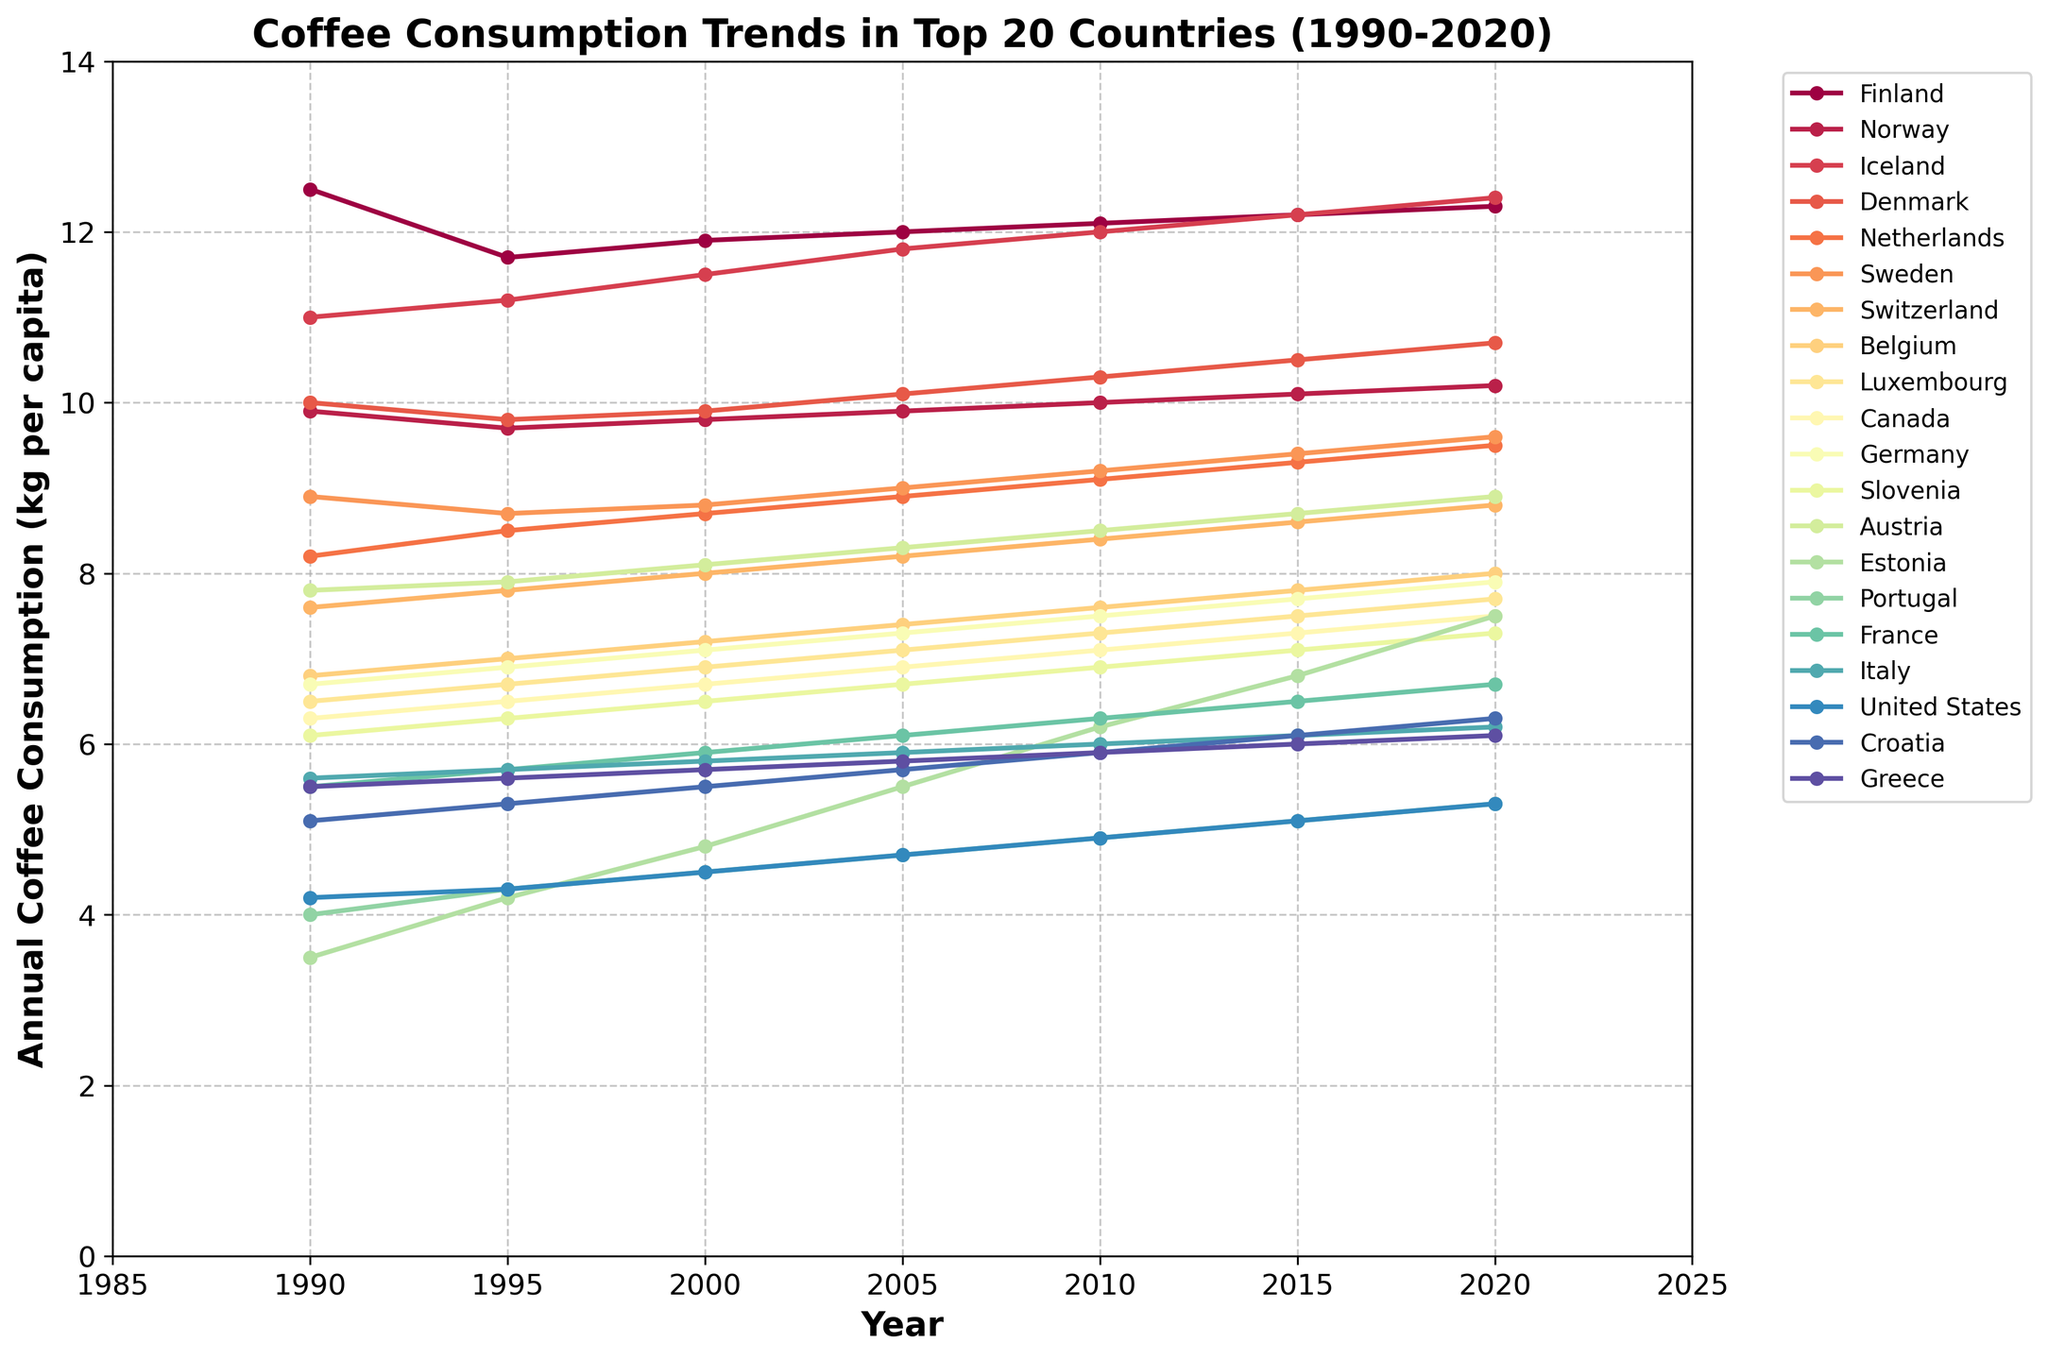what's the annual coffee consumption per capita in Finland and Norway in 2020, and what is their sum? The value of Finland's coffee consumption in 2020 is 12.3 kg per capita, and Norway's is 10.2 kg per capita. The sum is 12.3 + 10.2 = 22.5 kg per capita.
Answer: 22.5 Which country had the highest coffee consumption per capita in 1990? The country with the highest coffee consumption per capita in 1990 is Finland with 12.5 kg per capita.
Answer: Finland Between 1990 and 2020, which country had the most increase in annual coffee consumption per capita? For each country, subtract the 1990 value from the 2020 value and find the largest positive difference. For instance, Iceland increased from 11.0 kg to 12.4 kg, which is a 1.4 kg increase. Repeat for all countries. Iceland has the largest increase of 1.4 kg.
Answer: Iceland Which countries had a coffee consumption per capita greater than 10 kg in 2010? In 2010, look for countries with values greater than 10 kg per capita: Finland (12.1), Norway (10.0), Iceland (12.0), and Denmark (10.3).
Answer: Finland, Norway, Iceland, Denmark Compare the coffee consumption trends in the Netherlands and Germany from 1990 to 2020. Which country shows a more significant increase? Subtract each year's value in 1990 from 2020 for both countries. Netherlands: 9.5 - 8.2 = 1.3 kg and Germany: 7.9 - 6.7 = 1.2 kg. Hence, Netherlands has a slightly more significant increase.
Answer: Netherlands How did the coffee consumption per capita in Estonia change from 2000 to 2015? Estonia's coffee consumption went from 4.8 kg in 2000 to 6.8 kg in 2015. This is a difference of 6.8 - 4.8 = 2.0 kg.
Answer: Increased by 2.0 kg Identify the country with the smallest coffee consumption per capita in 2020 and specify its value. In 2020, the country with the smallest coffee consumption per capita is Portugal with 5.3 kg per capita.
Answer: Portugal, 5.3 kg What is the visual trend of coffee consumption in Finland from 1990 to 2020? Finland's coffee consumption shows a consistent increase from 12.5 kg in 1990 to 12.3 kg in 2020, remaining the highest throughout the period.
Answer: Consistent increase 